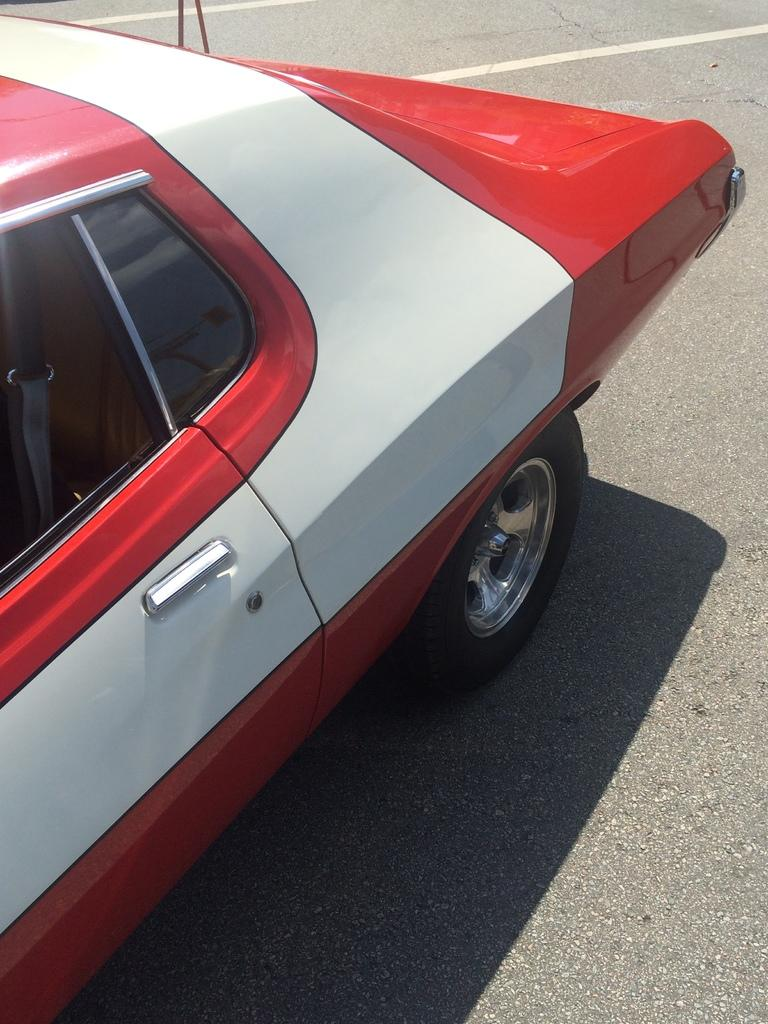What type of motor vehicle is in the image? The specific type of motor vehicle is not mentioned, but it is present in the image. Where is the motor vehicle located? The motor vehicle is on the road. What role does the mother play in the image? There is no mention of a mother or any person in the image, so it is not possible to answer this question. 